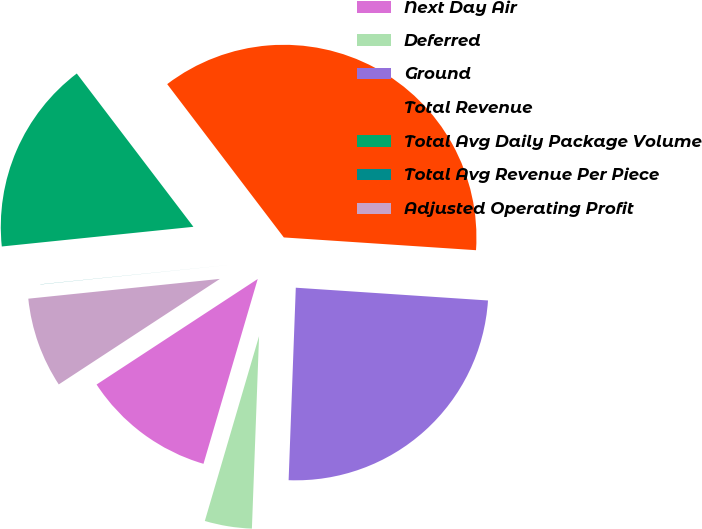Convert chart to OTSL. <chart><loc_0><loc_0><loc_500><loc_500><pie_chart><fcel>Next Day Air<fcel>Deferred<fcel>Ground<fcel>Total Revenue<fcel>Total Avg Daily Package Volume<fcel>Total Avg Revenue Per Piece<fcel>Adjusted Operating Profit<nl><fcel>11.23%<fcel>3.95%<fcel>24.54%<fcel>36.41%<fcel>16.28%<fcel>0.01%<fcel>7.59%<nl></chart> 